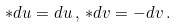Convert formula to latex. <formula><loc_0><loc_0><loc_500><loc_500>* d u = d u \, , \, * d v = - d v \, .</formula> 